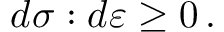<formula> <loc_0><loc_0><loc_500><loc_500>d { \sigma } \colon d { \varepsilon } \geq 0 \, .</formula> 